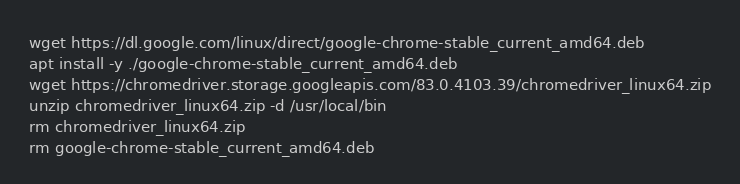<code> <loc_0><loc_0><loc_500><loc_500><_Bash_>wget https://dl.google.com/linux/direct/google-chrome-stable_current_amd64.deb
apt install -y ./google-chrome-stable_current_amd64.deb
wget https://chromedriver.storage.googleapis.com/83.0.4103.39/chromedriver_linux64.zip
unzip chromedriver_linux64.zip -d /usr/local/bin
rm chromedriver_linux64.zip
rm google-chrome-stable_current_amd64.deb</code> 